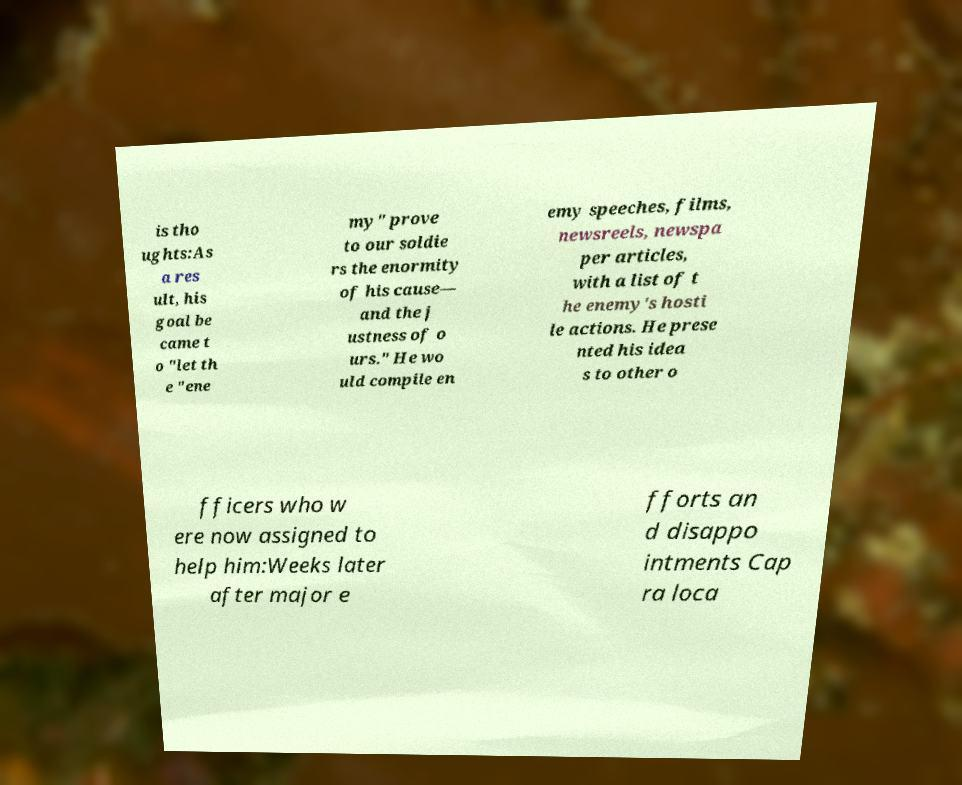Could you assist in decoding the text presented in this image and type it out clearly? is tho ughts:As a res ult, his goal be came t o "let th e "ene my" prove to our soldie rs the enormity of his cause— and the j ustness of o urs." He wo uld compile en emy speeches, films, newsreels, newspa per articles, with a list of t he enemy's hosti le actions. He prese nted his idea s to other o fficers who w ere now assigned to help him:Weeks later after major e fforts an d disappo intments Cap ra loca 